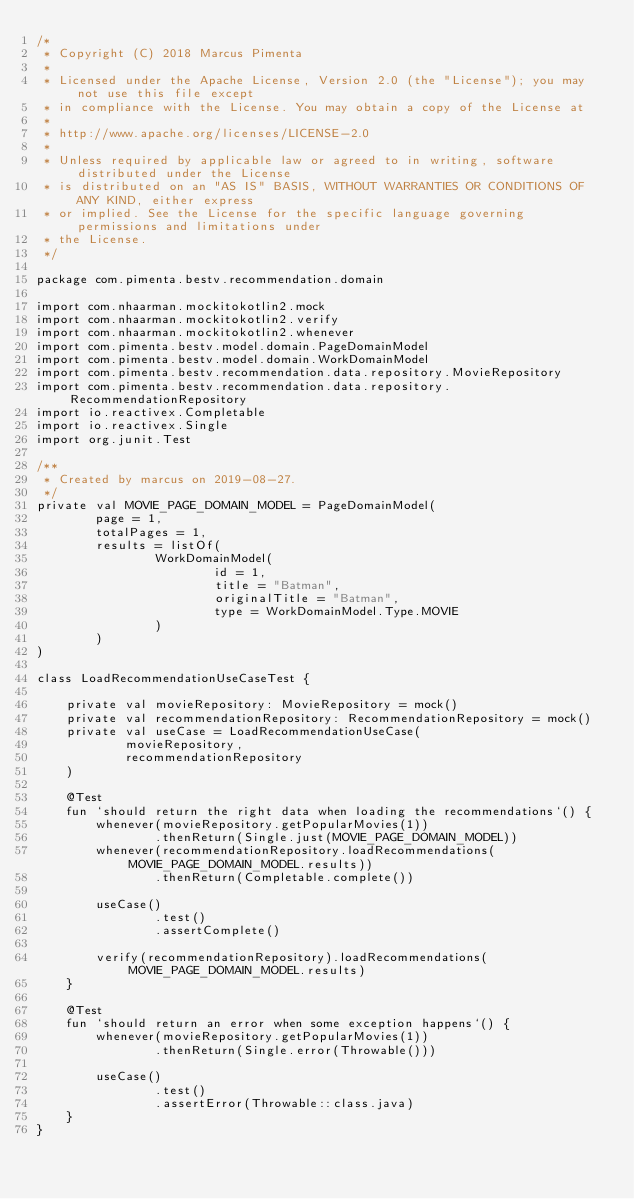<code> <loc_0><loc_0><loc_500><loc_500><_Kotlin_>/*
 * Copyright (C) 2018 Marcus Pimenta
 *
 * Licensed under the Apache License, Version 2.0 (the "License"); you may not use this file except
 * in compliance with the License. You may obtain a copy of the License at
 *
 * http://www.apache.org/licenses/LICENSE-2.0
 *
 * Unless required by applicable law or agreed to in writing, software distributed under the License
 * is distributed on an "AS IS" BASIS, WITHOUT WARRANTIES OR CONDITIONS OF ANY KIND, either express
 * or implied. See the License for the specific language governing permissions and limitations under
 * the License.
 */

package com.pimenta.bestv.recommendation.domain

import com.nhaarman.mockitokotlin2.mock
import com.nhaarman.mockitokotlin2.verify
import com.nhaarman.mockitokotlin2.whenever
import com.pimenta.bestv.model.domain.PageDomainModel
import com.pimenta.bestv.model.domain.WorkDomainModel
import com.pimenta.bestv.recommendation.data.repository.MovieRepository
import com.pimenta.bestv.recommendation.data.repository.RecommendationRepository
import io.reactivex.Completable
import io.reactivex.Single
import org.junit.Test

/**
 * Created by marcus on 2019-08-27.
 */
private val MOVIE_PAGE_DOMAIN_MODEL = PageDomainModel(
        page = 1,
        totalPages = 1,
        results = listOf(
                WorkDomainModel(
                        id = 1,
                        title = "Batman",
                        originalTitle = "Batman",
                        type = WorkDomainModel.Type.MOVIE
                )
        )
)

class LoadRecommendationUseCaseTest {

    private val movieRepository: MovieRepository = mock()
    private val recommendationRepository: RecommendationRepository = mock()
    private val useCase = LoadRecommendationUseCase(
            movieRepository,
            recommendationRepository
    )

    @Test
    fun `should return the right data when loading the recommendations`() {
        whenever(movieRepository.getPopularMovies(1))
                .thenReturn(Single.just(MOVIE_PAGE_DOMAIN_MODEL))
        whenever(recommendationRepository.loadRecommendations(MOVIE_PAGE_DOMAIN_MODEL.results))
                .thenReturn(Completable.complete())

        useCase()
                .test()
                .assertComplete()

        verify(recommendationRepository).loadRecommendations(MOVIE_PAGE_DOMAIN_MODEL.results)
    }

    @Test
    fun `should return an error when some exception happens`() {
        whenever(movieRepository.getPopularMovies(1))
                .thenReturn(Single.error(Throwable()))

        useCase()
                .test()
                .assertError(Throwable::class.java)
    }
}
</code> 